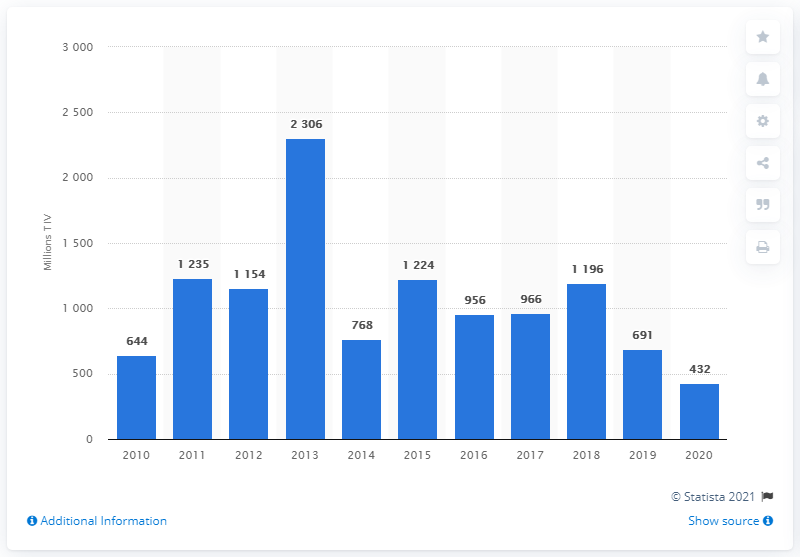Can you explain the trend in the UAE's arms imports over the past decade? The graph shows a fluctuating trend in the UAE's arms imports over the past decade. After a gradual increase from 2010, reaching a peak in 2014, there is a notable decline in subsequent years, with a sharp fall in 2020. Possible factors could include varying security needs, budget constraints, or shifts in foreign policy and strategic alliances. 